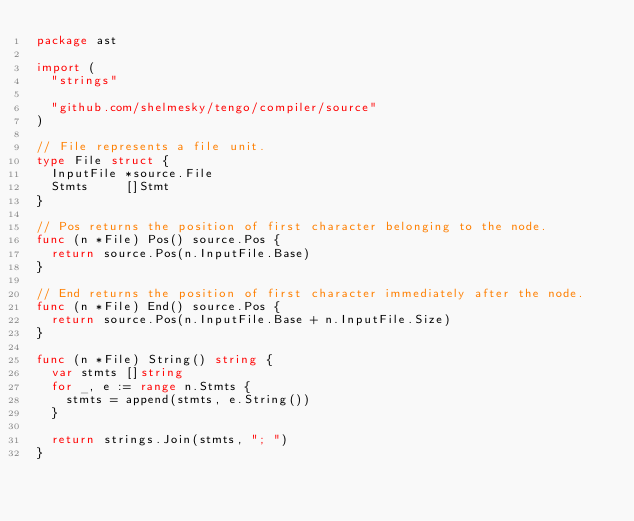Convert code to text. <code><loc_0><loc_0><loc_500><loc_500><_Go_>package ast

import (
	"strings"

	"github.com/shelmesky/tengo/compiler/source"
)

// File represents a file unit.
type File struct {
	InputFile *source.File
	Stmts     []Stmt
}

// Pos returns the position of first character belonging to the node.
func (n *File) Pos() source.Pos {
	return source.Pos(n.InputFile.Base)
}

// End returns the position of first character immediately after the node.
func (n *File) End() source.Pos {
	return source.Pos(n.InputFile.Base + n.InputFile.Size)
}

func (n *File) String() string {
	var stmts []string
	for _, e := range n.Stmts {
		stmts = append(stmts, e.String())
	}

	return strings.Join(stmts, "; ")
}
</code> 